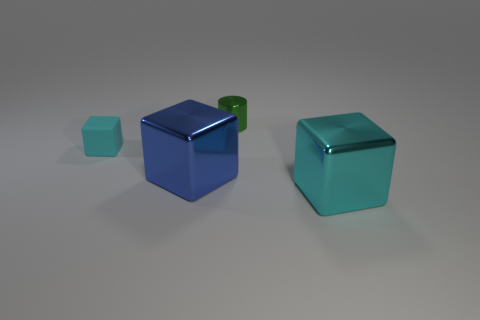What material is the cyan object on the left side of the big metal cube that is left of the small metallic object?
Provide a succinct answer. Rubber. Is the color of the thing behind the cyan matte thing the same as the small matte thing?
Your response must be concise. No. Is there any other thing that is made of the same material as the small block?
Give a very brief answer. No. What number of blue objects are the same shape as the tiny cyan matte object?
Keep it short and to the point. 1. There is a blue block that is the same material as the cylinder; what size is it?
Provide a short and direct response. Large. There is a large shiny object on the left side of the large metallic block to the right of the tiny green metal cylinder; are there any large things that are in front of it?
Keep it short and to the point. Yes. Is the size of the metallic object that is on the right side of the cylinder the same as the cylinder?
Provide a succinct answer. No. How many blue shiny objects have the same size as the cyan shiny object?
Your answer should be compact. 1. What is the size of the other metallic cube that is the same color as the tiny block?
Make the answer very short. Large. Does the metallic cylinder have the same color as the rubber cube?
Your answer should be compact. No. 